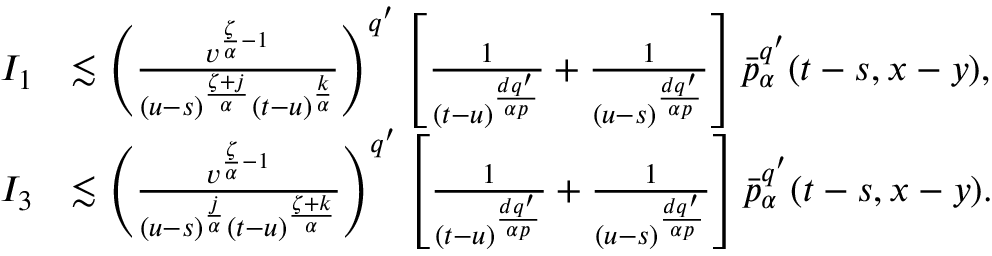Convert formula to latex. <formula><loc_0><loc_0><loc_500><loc_500>\begin{array} { r l } { I _ { 1 } } & { \lesssim \left ( \frac { v ^ { \frac { \zeta } { \alpha } - 1 } } { ( u - s ) ^ { \frac { \zeta + j } { \alpha } } ( t - u ) ^ { \frac { k } { \alpha } } } \right ) ^ { q ^ { \prime } } \left [ \frac { 1 } { ( t - u ) ^ { \frac { d q ^ { \prime } } { \alpha p } } } + \frac { 1 } { ( u - s ) ^ { \frac { d q ^ { \prime } } { \alpha p } } } \right ] \bar { p } _ { \alpha } ^ { q ^ { \prime } } ( t - s , x - y ) , } \\ { I _ { 3 } } & { \lesssim \left ( \frac { v ^ { \frac { \zeta } { \alpha } - 1 } } { ( u - s ) ^ { \frac { j } { \alpha } } ( t - u ) ^ { \frac { \zeta + k } { \alpha } } } \right ) ^ { q ^ { \prime } } \left [ \frac { 1 } { ( t - u ) ^ { \frac { d q ^ { \prime } } { \alpha p } } } + \frac { 1 } { ( u - s ) ^ { \frac { d q ^ { \prime } } { \alpha p } } } \right ] \bar { p } _ { \alpha } ^ { q ^ { \prime } } ( t - s , x - y ) . } \end{array}</formula> 